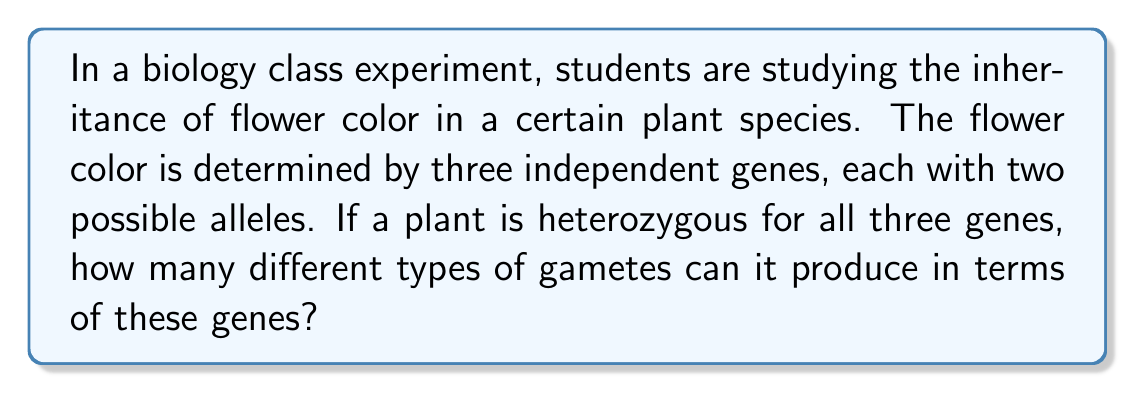Can you solve this math problem? Let's approach this step-by-step:

1) First, we need to understand what heterozygous means. A heterozygous individual has two different alleles for a given gene.

2) We are told that there are three independent genes, each with two possible alleles. Let's represent these as:
   Gene 1: A and a
   Gene 2: B and b
   Gene 3: C and c

3) A plant that is heterozygous for all three genes would have the genotype: AaBbCc

4) When forming gametes, each gene segregates independently (Mendel's Law of Independent Assortment). This means that for each gene, there are two possibilities:
   Gene 1: A or a
   Gene 2: B or b
   Gene 3: C or c

5) To determine the total number of possible gamete types, we need to calculate the number of ways to combine these possibilities.

6) This is a perfect scenario for applying the multiplication principle of counting. For each gene, there are 2 choices, and we have 3 genes in total.

7) Therefore, the total number of possible gamete types is:

   $$ 2 \times 2 \times 2 = 2^3 = 8 $$

8) We can list out all these possibilities to verify:
   ABC, ABc, AbC, Abc, aBC, aBc, abC, abc

Thus, there are 8 different types of gametes that can be produced.
Answer: 8 